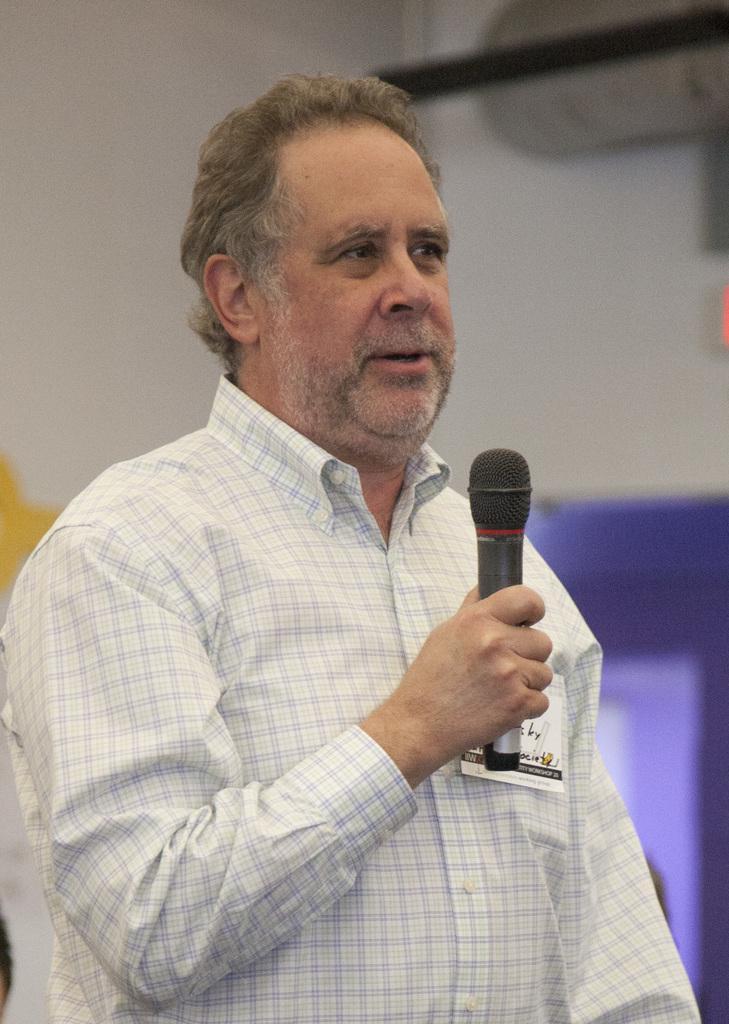Can you describe this image briefly? In this image I can see a man holding a mic. 